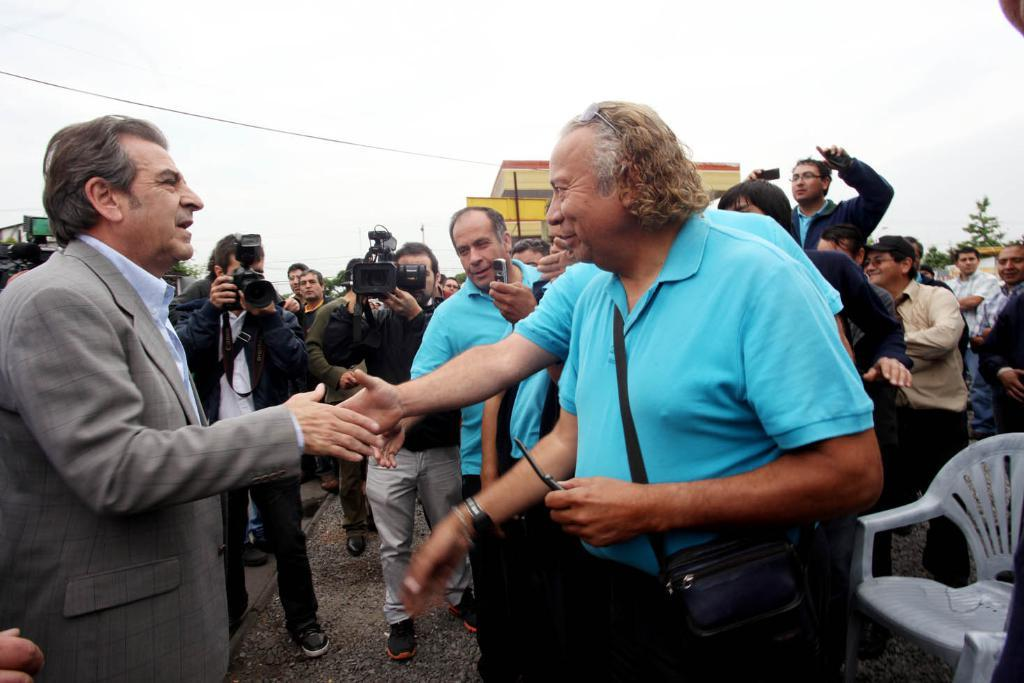What are the two persons in the image doing? The two persons in the image are shaking hands. What can be seen in the background of the image? There are people holding cameras in the background, and there is a building visible as well. What is visible in the sky in the image? The sky is visible in the image, but no specific details about the sky are mentioned in the facts. Can you describe the setting of the image? The image appears to be taken outdoors, given the presence of the sky and the building in the background. What type of fruit is being offered by the person in authority in the image? There is no person in authority or fruit present in the image. 